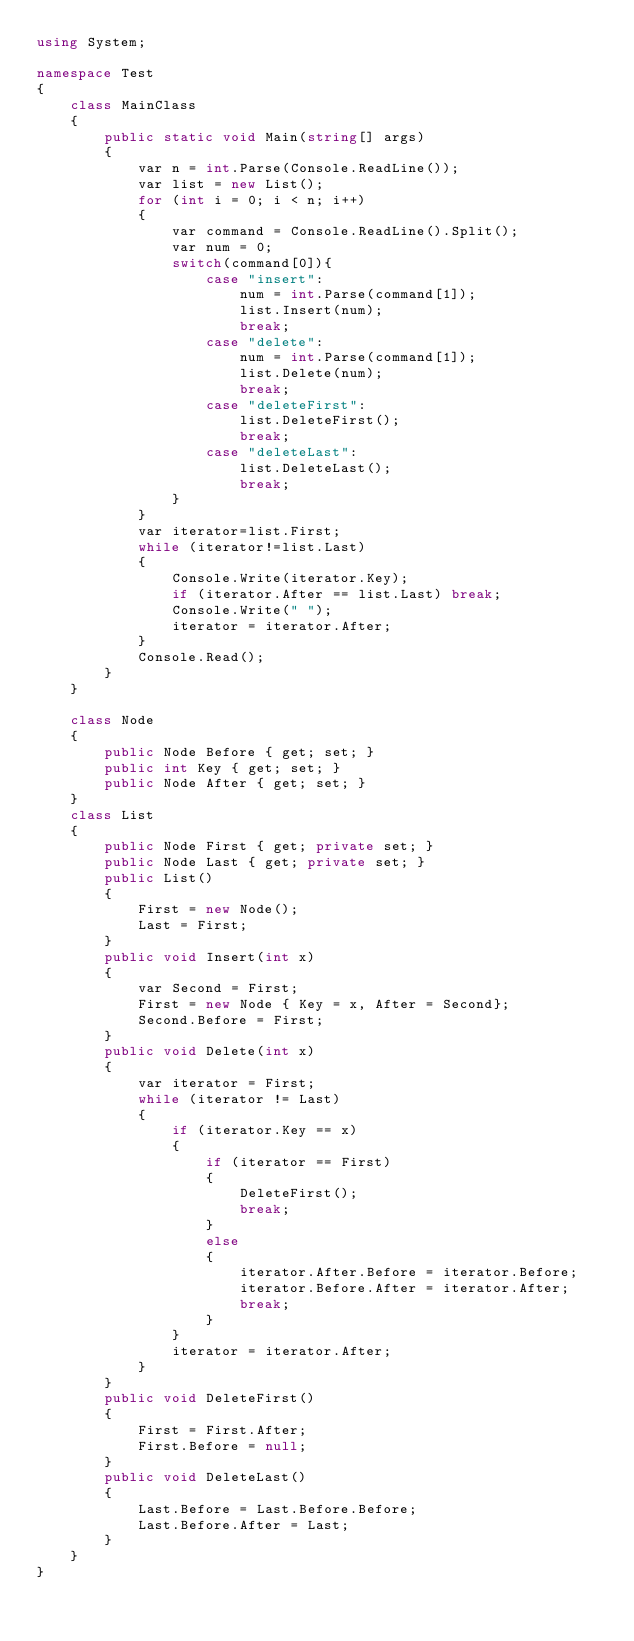Convert code to text. <code><loc_0><loc_0><loc_500><loc_500><_C#_>using System;

namespace Test
{
    class MainClass
    {
        public static void Main(string[] args)
        {
            var n = int.Parse(Console.ReadLine());
            var list = new List();
            for (int i = 0; i < n; i++)
            {
                var command = Console.ReadLine().Split();
                var num = 0;
                switch(command[0]){
                    case "insert":
                        num = int.Parse(command[1]);
                        list.Insert(num);
                        break;
                    case "delete":
                        num = int.Parse(command[1]);
                        list.Delete(num);
                        break;
                    case "deleteFirst":
                        list.DeleteFirst();
                        break;
                    case "deleteLast":
                        list.DeleteLast();
                        break;
                }
            }
            var iterator=list.First;
            while (iterator!=list.Last)
            {
                Console.Write(iterator.Key);
                if (iterator.After == list.Last) break;
                Console.Write(" ");
                iterator = iterator.After;
            }
            Console.Read();
        }
    }

    class Node
    {
        public Node Before { get; set; }
        public int Key { get; set; }
        public Node After { get; set; }
    }
    class List
    {
        public Node First { get; private set; }
        public Node Last { get; private set; }
        public List()
        {
            First = new Node();
            Last = First;
        }
        public void Insert(int x)
        {
            var Second = First;
            First = new Node { Key = x, After = Second};
            Second.Before = First;
        }
        public void Delete(int x)
        {
            var iterator = First;
            while (iterator != Last)
            {
                if (iterator.Key == x)
                {
                    if (iterator == First)
                    {
                        DeleteFirst();
                        break;
                    }
                    else
                    {
                        iterator.After.Before = iterator.Before;
                        iterator.Before.After = iterator.After;
                        break;
                    }
                }
                iterator = iterator.After;
            }
        }
        public void DeleteFirst()
        {
            First = First.After;
            First.Before = null;
        }
        public void DeleteLast()
        {
            Last.Before = Last.Before.Before;
            Last.Before.After = Last;
        }
    }
}</code> 